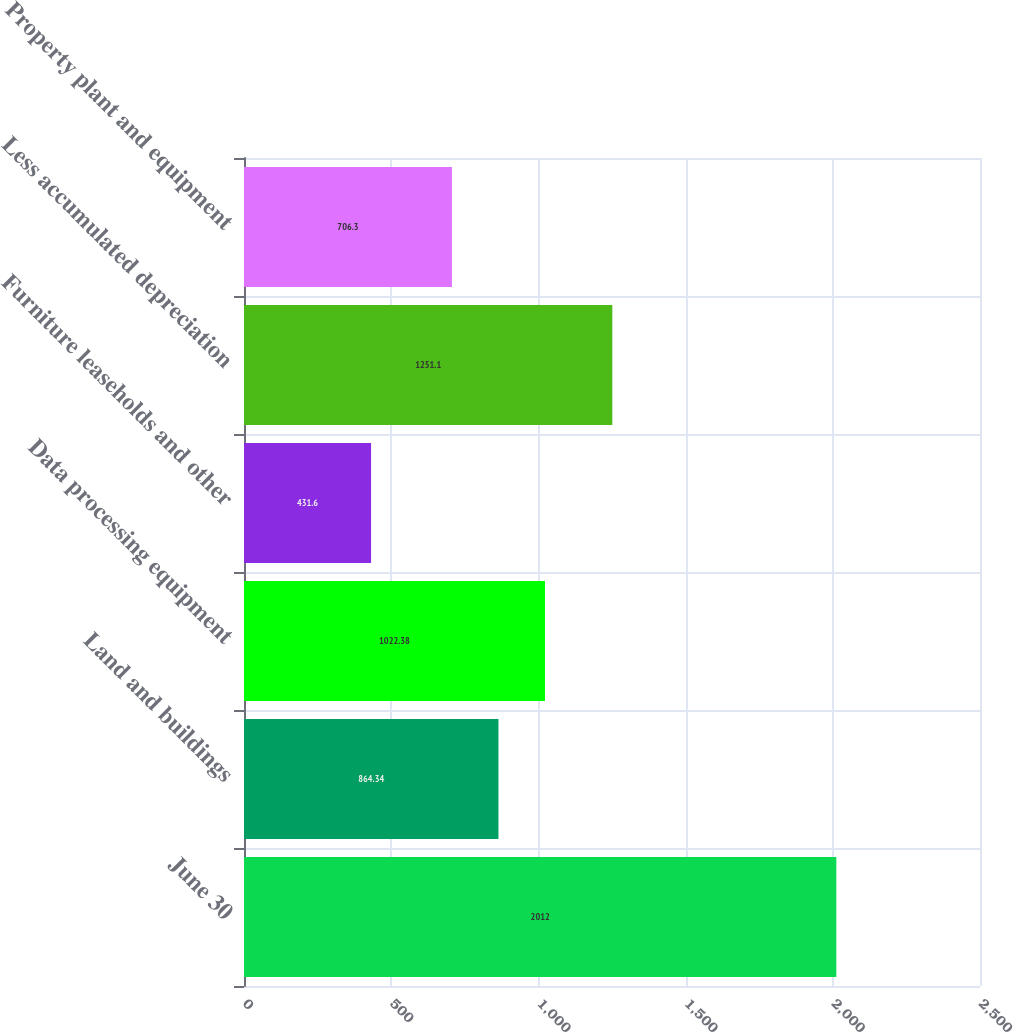Convert chart. <chart><loc_0><loc_0><loc_500><loc_500><bar_chart><fcel>June 30<fcel>Land and buildings<fcel>Data processing equipment<fcel>Furniture leaseholds and other<fcel>Less accumulated depreciation<fcel>Property plant and equipment<nl><fcel>2012<fcel>864.34<fcel>1022.38<fcel>431.6<fcel>1251.1<fcel>706.3<nl></chart> 